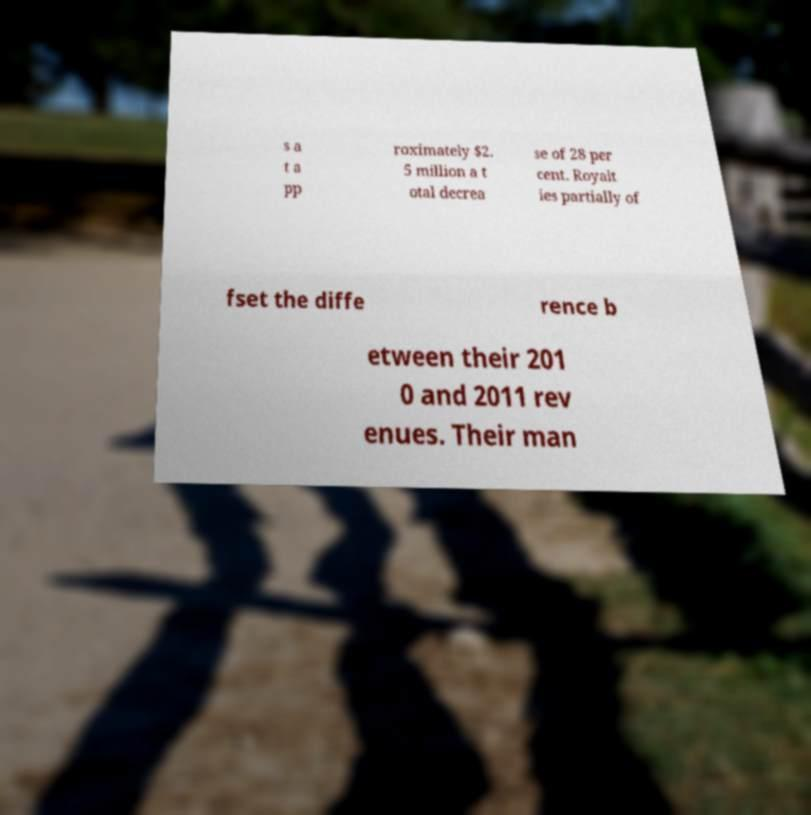I need the written content from this picture converted into text. Can you do that? s a t a pp roximately $2. 5 million a t otal decrea se of 28 per cent. Royalt ies partially of fset the diffe rence b etween their 201 0 and 2011 rev enues. Their man 